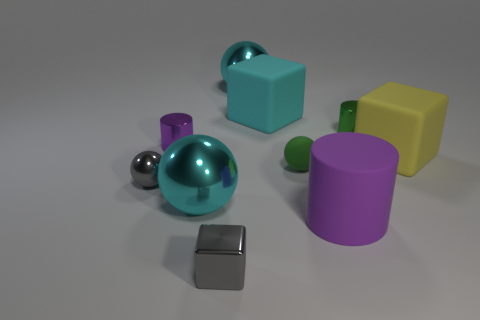There is another tiny object that is the same shape as the yellow thing; what is it made of?
Your answer should be compact. Metal. There is a big block that is in front of the small green metallic object; what color is it?
Ensure brevity in your answer.  Yellow. Is the tiny green ball made of the same material as the purple cylinder that is in front of the purple shiny thing?
Make the answer very short. Yes. What is the small purple cylinder made of?
Make the answer very short. Metal. There is a tiny green thing that is made of the same material as the small purple cylinder; what shape is it?
Your response must be concise. Cylinder. How many other objects are the same shape as the tiny rubber thing?
Give a very brief answer. 3. There is a large cyan cube; how many large cyan rubber objects are in front of it?
Provide a short and direct response. 0. There is a purple thing that is behind the small matte ball; does it have the same size as the cyan object in front of the green matte ball?
Make the answer very short. No. How many other objects are there of the same size as the gray shiny cube?
Make the answer very short. 4. The small purple cylinder that is behind the small sphere right of the purple cylinder that is behind the large purple rubber cylinder is made of what material?
Keep it short and to the point. Metal. 